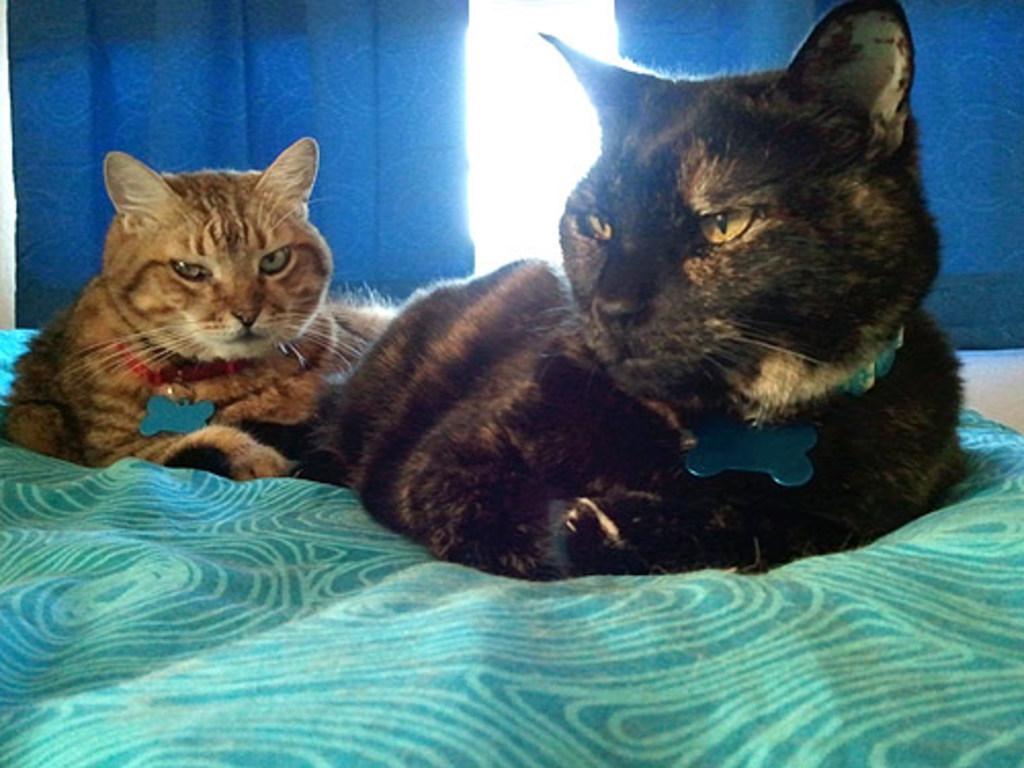Can you describe this image briefly? In the foreground of this image, there are two cats on the bed. In the background, there are two blue curtains and it seems like a glass in the middle. 